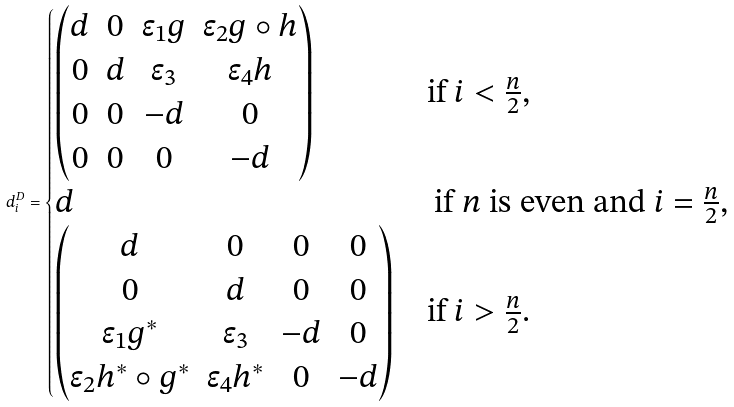<formula> <loc_0><loc_0><loc_500><loc_500>d ^ { D } _ { i } = \begin{cases} \begin{pmatrix} d & 0 & \epsilon _ { 1 } g & \epsilon _ { 2 } g \circ h \\ 0 & d & \epsilon _ { 3 } & \epsilon _ { 4 } h \\ 0 & 0 & - d & 0 \\ 0 & 0 & 0 & - d \end{pmatrix} & \text {if $i < \frac{n}{2}$,} \\ d & \text { if $n$ is even and $i = \frac{n}{2}$,} \\ \begin{pmatrix} d & 0 & 0 & 0 \\ 0 & d & 0 & 0 \\ \epsilon _ { 1 } g ^ { * } & \epsilon _ { 3 } & - d & 0 \\ \epsilon _ { 2 } h ^ { * } \circ g ^ { * } & \epsilon _ { 4 } h ^ { * } & 0 & - d \end{pmatrix} & \text {if $i > \frac{n}{2}$.} \\ \end{cases}</formula> 